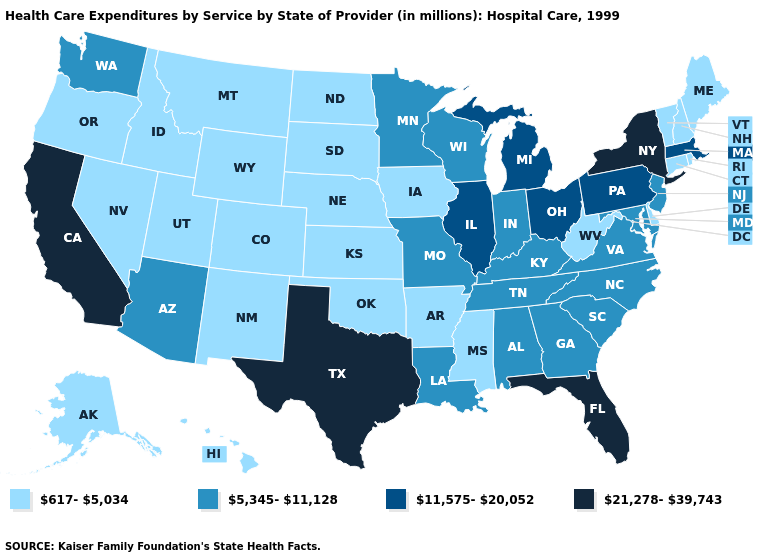What is the lowest value in the USA?
Concise answer only. 617-5,034. Which states have the lowest value in the West?
Give a very brief answer. Alaska, Colorado, Hawaii, Idaho, Montana, Nevada, New Mexico, Oregon, Utah, Wyoming. Does Vermont have the lowest value in the Northeast?
Be succinct. Yes. What is the lowest value in states that border Wyoming?
Quick response, please. 617-5,034. What is the value of Mississippi?
Short answer required. 617-5,034. What is the value of Montana?
Give a very brief answer. 617-5,034. Which states have the highest value in the USA?
Short answer required. California, Florida, New York, Texas. Does the map have missing data?
Write a very short answer. No. What is the value of Washington?
Answer briefly. 5,345-11,128. Does North Carolina have the same value as North Dakota?
Concise answer only. No. What is the lowest value in the USA?
Keep it brief. 617-5,034. What is the value of Illinois?
Quick response, please. 11,575-20,052. What is the value of Iowa?
Answer briefly. 617-5,034. What is the value of Nebraska?
Give a very brief answer. 617-5,034. What is the highest value in states that border South Carolina?
Keep it brief. 5,345-11,128. 